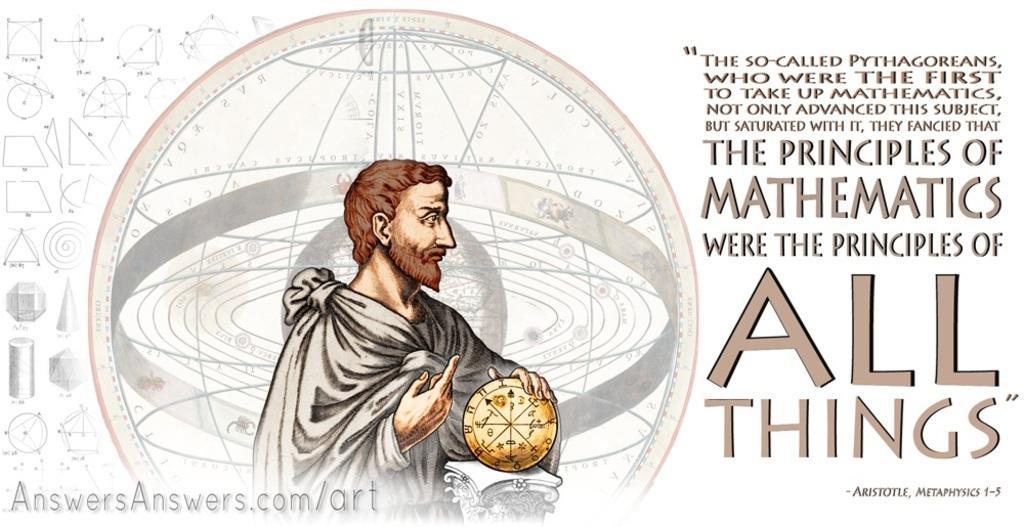In one or two sentences, can you explain what this image depicts? In this image I can see the person's hand on the object. Back I can see few shapes and something is written on it. Background is in white color. 